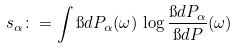Convert formula to latex. <formula><loc_0><loc_0><loc_500><loc_500>s _ { \alpha } \colon = \int \i d P _ { \alpha } ( \omega ) \, \log \frac { \i d P _ { \alpha } } { \i d P } ( \omega )</formula> 